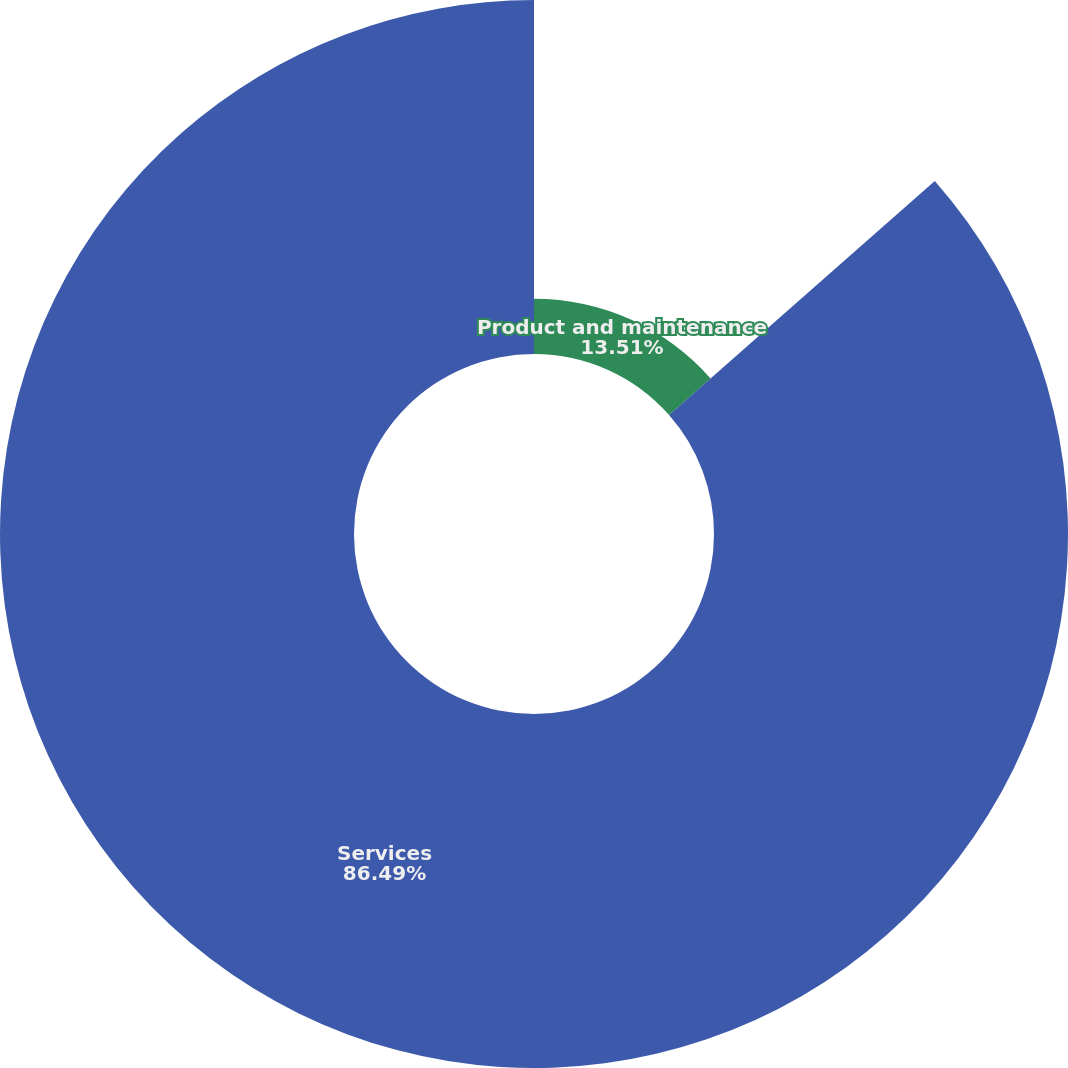<chart> <loc_0><loc_0><loc_500><loc_500><pie_chart><fcel>Product and maintenance<fcel>Services<nl><fcel>13.51%<fcel>86.49%<nl></chart> 